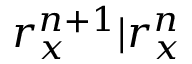<formula> <loc_0><loc_0><loc_500><loc_500>r _ { x } ^ { n + 1 } | r _ { x } ^ { n }</formula> 